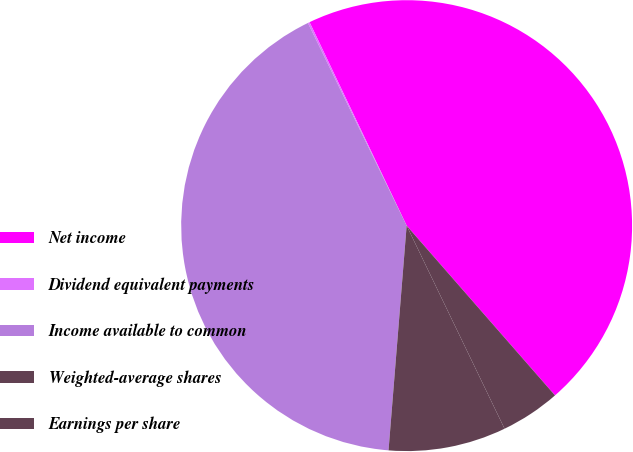Convert chart. <chart><loc_0><loc_0><loc_500><loc_500><pie_chart><fcel>Net income<fcel>Dividend equivalent payments<fcel>Income available to common<fcel>Weighted-average shares<fcel>Earnings per share<nl><fcel>45.65%<fcel>0.13%<fcel>41.5%<fcel>8.43%<fcel>4.28%<nl></chart> 